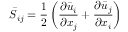Convert formula to latex. <formula><loc_0><loc_0><loc_500><loc_500>{ \bar { S } } _ { i j } = { \frac { 1 } { 2 } } \left ( { \frac { \partial { \bar { u } } _ { i } } { \partial x _ { j } } } + { \frac { \partial { \bar { u } } _ { j } } { \partial x _ { i } } } \right )</formula> 